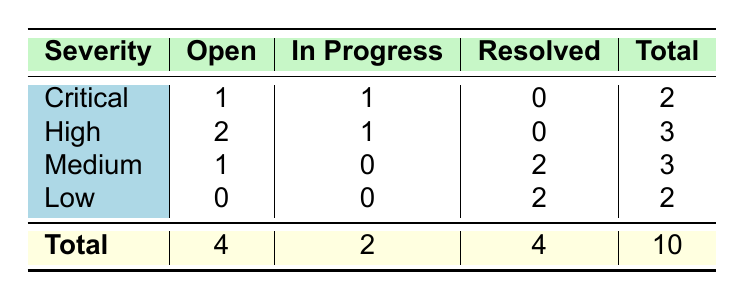What is the total number of bugs reported? To find the total number of bugs, I look at the last row of the table where the total for each category is summed up. The total number of bugs is given as 10.
Answer: 10 How many Critical bugs are currently Open? In the row for Critical severity, the column for Open bugs shows a count of 1.
Answer: 1 What is the total number of bugs that are Resolved? By checking the total in the Resolved column, I see that there are 4 bugs marked as Resolved.
Answer: 4 Is there any bug with Low severity that is still Open? Looking at the Low severity row, I see that the count in the Open column is 0, indicating there are no Open bugs in that severity category.
Answer: No How many total Medium severity bugs are there? Summing up the totals in the Medium severity row, I can see that there are 3 bugs (1 Open, 0 In Progress, and 2 Resolved).
Answer: 3 What is the difference between the number of Open and Resolved bugs? From the total row, the number of Open bugs is 4 and Resolved bugs is 4. The difference is calculated as 4 - 4 = 0.
Answer: 0 How many bugs are currently In Progress across all severities? Looking at the In Progress column totals, I see there are 2 bugs listed under that status.
Answer: 2 What percentage of the total bugs are classified as High severity? The total number of High severity bugs is 3, and total bugs reported is 10. The percentage is calculated as (3 / 10) * 100 = 30%.
Answer: 30% Are there more Open bugs or Resolved bugs? Comparing the Total counts in the Open and Resolved columns, there are 4 Open bugs and 4 Resolved bugs. Since they are equal, the answer is that there are not more of either.
Answer: Neither If we add the In Progress bugs to Resolved bugs, how many bugs will we have? The In Progress count is 2 and the Resolved count is 4. Adding them gives 2 + 4 = 6.
Answer: 6 